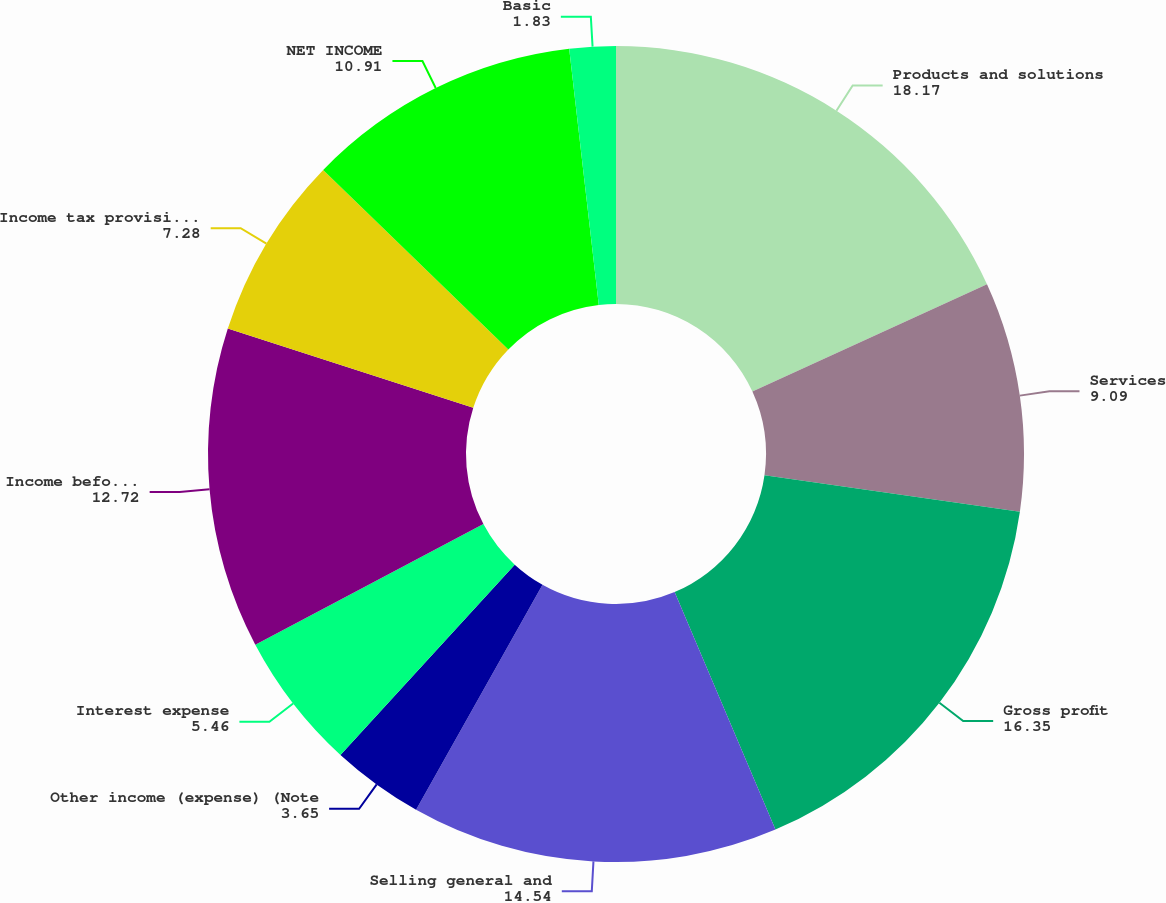Convert chart to OTSL. <chart><loc_0><loc_0><loc_500><loc_500><pie_chart><fcel>Products and solutions<fcel>Services<fcel>Gross profit<fcel>Selling general and<fcel>Other income (expense) (Note<fcel>Interest expense<fcel>Income before income taxes<fcel>Income tax provision (Note 14)<fcel>NET INCOME<fcel>Basic<nl><fcel>18.17%<fcel>9.09%<fcel>16.35%<fcel>14.54%<fcel>3.65%<fcel>5.46%<fcel>12.72%<fcel>7.28%<fcel>10.91%<fcel>1.83%<nl></chart> 